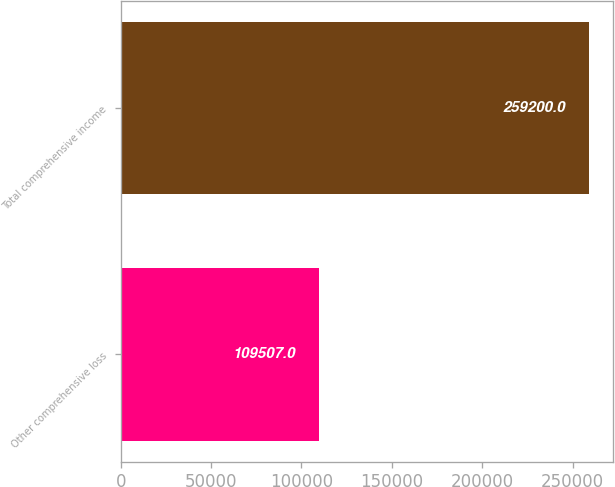Convert chart to OTSL. <chart><loc_0><loc_0><loc_500><loc_500><bar_chart><fcel>Other comprehensive loss<fcel>Total comprehensive income<nl><fcel>109507<fcel>259200<nl></chart> 